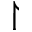<formula> <loc_0><loc_0><loc_500><loc_500>\upharpoonright</formula> 